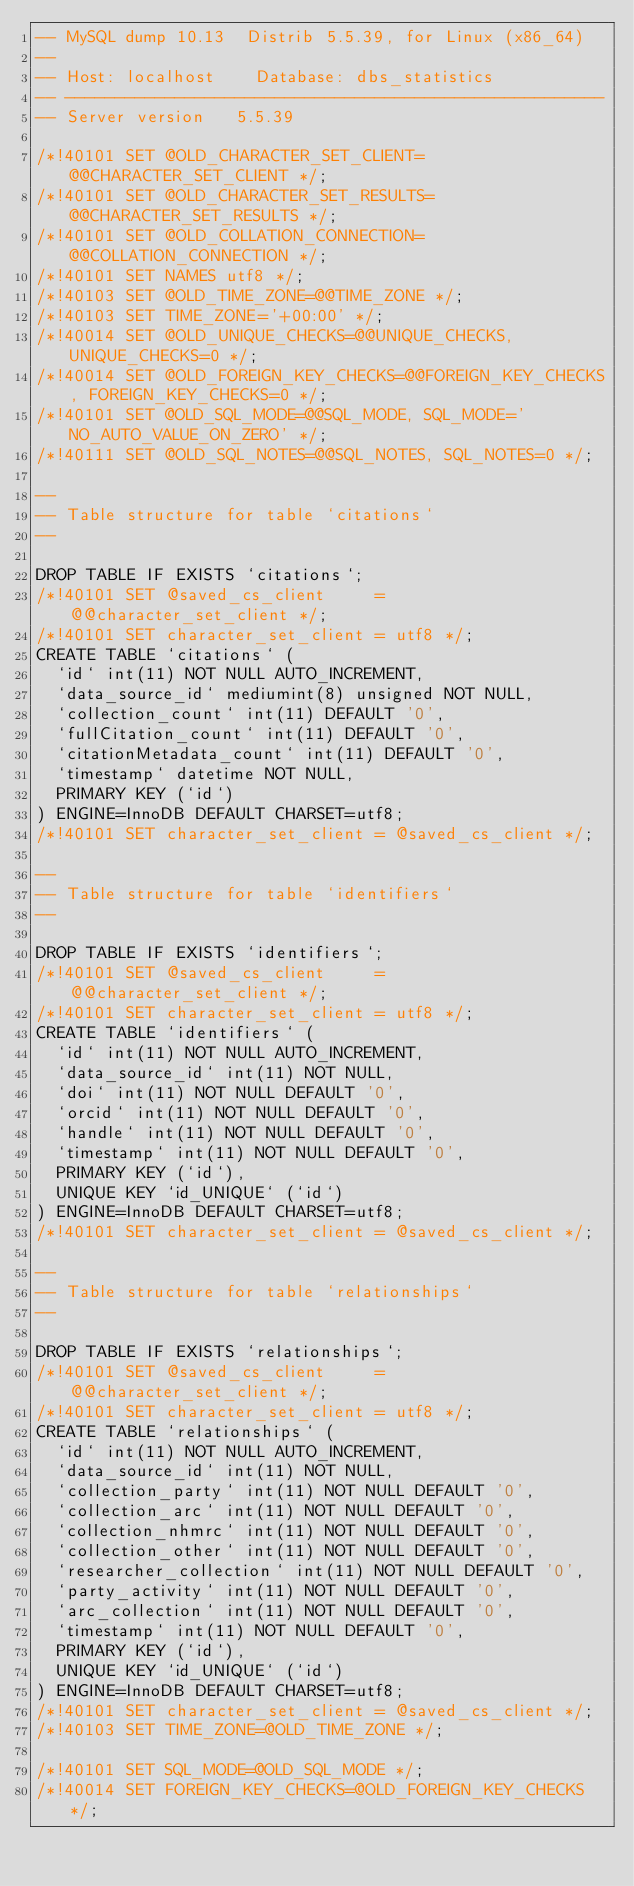<code> <loc_0><loc_0><loc_500><loc_500><_SQL_>-- MySQL dump 10.13  Distrib 5.5.39, for Linux (x86_64)
--
-- Host: localhost    Database: dbs_statistics
-- ------------------------------------------------------
-- Server version	5.5.39

/*!40101 SET @OLD_CHARACTER_SET_CLIENT=@@CHARACTER_SET_CLIENT */;
/*!40101 SET @OLD_CHARACTER_SET_RESULTS=@@CHARACTER_SET_RESULTS */;
/*!40101 SET @OLD_COLLATION_CONNECTION=@@COLLATION_CONNECTION */;
/*!40101 SET NAMES utf8 */;
/*!40103 SET @OLD_TIME_ZONE=@@TIME_ZONE */;
/*!40103 SET TIME_ZONE='+00:00' */;
/*!40014 SET @OLD_UNIQUE_CHECKS=@@UNIQUE_CHECKS, UNIQUE_CHECKS=0 */;
/*!40014 SET @OLD_FOREIGN_KEY_CHECKS=@@FOREIGN_KEY_CHECKS, FOREIGN_KEY_CHECKS=0 */;
/*!40101 SET @OLD_SQL_MODE=@@SQL_MODE, SQL_MODE='NO_AUTO_VALUE_ON_ZERO' */;
/*!40111 SET @OLD_SQL_NOTES=@@SQL_NOTES, SQL_NOTES=0 */;

--
-- Table structure for table `citations`
--

DROP TABLE IF EXISTS `citations`;
/*!40101 SET @saved_cs_client     = @@character_set_client */;
/*!40101 SET character_set_client = utf8 */;
CREATE TABLE `citations` (
  `id` int(11) NOT NULL AUTO_INCREMENT,
  `data_source_id` mediumint(8) unsigned NOT NULL,
  `collection_count` int(11) DEFAULT '0',
  `fullCitation_count` int(11) DEFAULT '0',
  `citationMetadata_count` int(11) DEFAULT '0',
  `timestamp` datetime NOT NULL,
  PRIMARY KEY (`id`)
) ENGINE=InnoDB DEFAULT CHARSET=utf8;
/*!40101 SET character_set_client = @saved_cs_client */;

--
-- Table structure for table `identifiers`
--

DROP TABLE IF EXISTS `identifiers`;
/*!40101 SET @saved_cs_client     = @@character_set_client */;
/*!40101 SET character_set_client = utf8 */;
CREATE TABLE `identifiers` (
  `id` int(11) NOT NULL AUTO_INCREMENT,
  `data_source_id` int(11) NOT NULL,
  `doi` int(11) NOT NULL DEFAULT '0',
  `orcid` int(11) NOT NULL DEFAULT '0',
  `handle` int(11) NOT NULL DEFAULT '0',
  `timestamp` int(11) NOT NULL DEFAULT '0',
  PRIMARY KEY (`id`),
  UNIQUE KEY `id_UNIQUE` (`id`)
) ENGINE=InnoDB DEFAULT CHARSET=utf8;
/*!40101 SET character_set_client = @saved_cs_client */;

--
-- Table structure for table `relationships`
--

DROP TABLE IF EXISTS `relationships`;
/*!40101 SET @saved_cs_client     = @@character_set_client */;
/*!40101 SET character_set_client = utf8 */;
CREATE TABLE `relationships` (
  `id` int(11) NOT NULL AUTO_INCREMENT,
  `data_source_id` int(11) NOT NULL,
  `collection_party` int(11) NOT NULL DEFAULT '0',
  `collection_arc` int(11) NOT NULL DEFAULT '0',
  `collection_nhmrc` int(11) NOT NULL DEFAULT '0',
  `collection_other` int(11) NOT NULL DEFAULT '0',
  `researcher_collection` int(11) NOT NULL DEFAULT '0',
  `party_activity` int(11) NOT NULL DEFAULT '0',
  `arc_collection` int(11) NOT NULL DEFAULT '0',
  `timestamp` int(11) NOT NULL DEFAULT '0',
  PRIMARY KEY (`id`),
  UNIQUE KEY `id_UNIQUE` (`id`)
) ENGINE=InnoDB DEFAULT CHARSET=utf8;
/*!40101 SET character_set_client = @saved_cs_client */;
/*!40103 SET TIME_ZONE=@OLD_TIME_ZONE */;

/*!40101 SET SQL_MODE=@OLD_SQL_MODE */;
/*!40014 SET FOREIGN_KEY_CHECKS=@OLD_FOREIGN_KEY_CHECKS */;</code> 